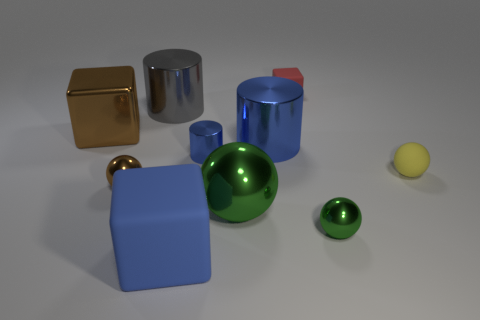Is the cube that is left of the big blue matte thing made of the same material as the yellow thing?
Provide a short and direct response. No. What number of tiny yellow things are the same material as the tiny blue cylinder?
Offer a very short reply. 0. Are there more large rubber blocks that are behind the yellow object than small spheres?
Keep it short and to the point. No. What is the size of the other sphere that is the same color as the large metallic sphere?
Keep it short and to the point. Small. Are there any other small yellow matte objects that have the same shape as the yellow rubber thing?
Make the answer very short. No. How many things are blue things or metallic balls?
Offer a very short reply. 6. What number of tiny yellow balls are left of the large cylinder in front of the block left of the brown sphere?
Offer a terse response. 0. There is a large brown object that is the same shape as the tiny red thing; what is it made of?
Your answer should be compact. Metal. The small object that is to the right of the large green thing and behind the small yellow thing is made of what material?
Keep it short and to the point. Rubber. Is the number of large gray metallic cylinders on the right side of the large rubber thing less than the number of blue metal cylinders to the right of the yellow ball?
Make the answer very short. No. 